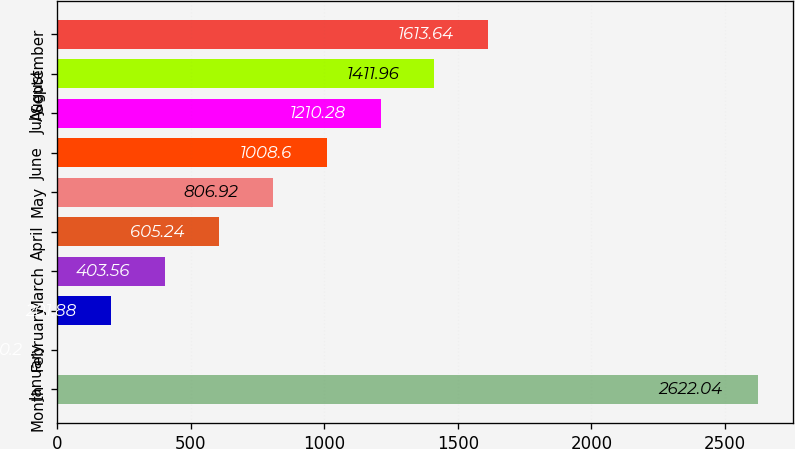Convert chart to OTSL. <chart><loc_0><loc_0><loc_500><loc_500><bar_chart><fcel>Month<fcel>January<fcel>February<fcel>March<fcel>April<fcel>May<fcel>June<fcel>July<fcel>August<fcel>September<nl><fcel>2622.04<fcel>0.2<fcel>201.88<fcel>403.56<fcel>605.24<fcel>806.92<fcel>1008.6<fcel>1210.28<fcel>1411.96<fcel>1613.64<nl></chart> 